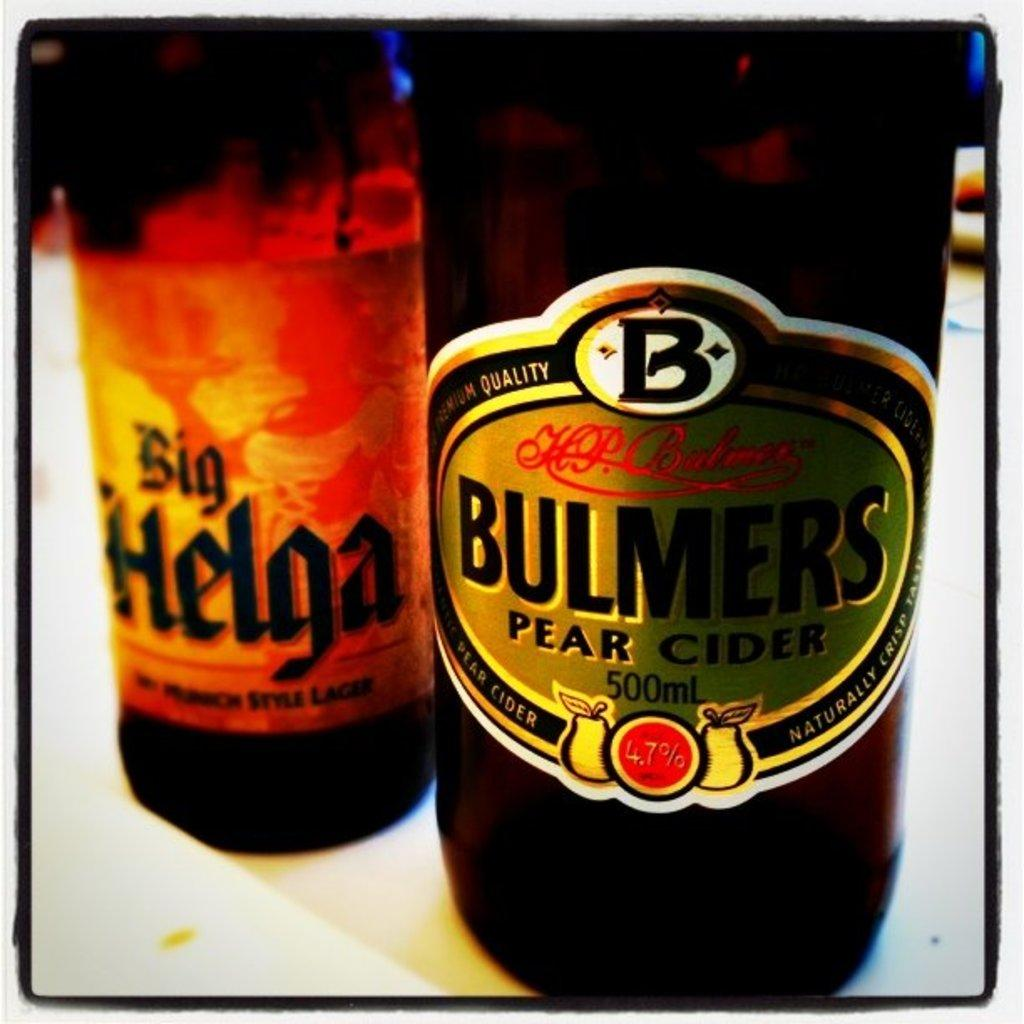<image>
Write a terse but informative summary of the picture. A bottle of Big Helga is slightlyy behind a bottle of Bulmers Pear Cider 